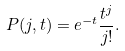<formula> <loc_0><loc_0><loc_500><loc_500>P ( j , t ) = e ^ { - t } \frac { t ^ { j } } { j ! } .</formula> 